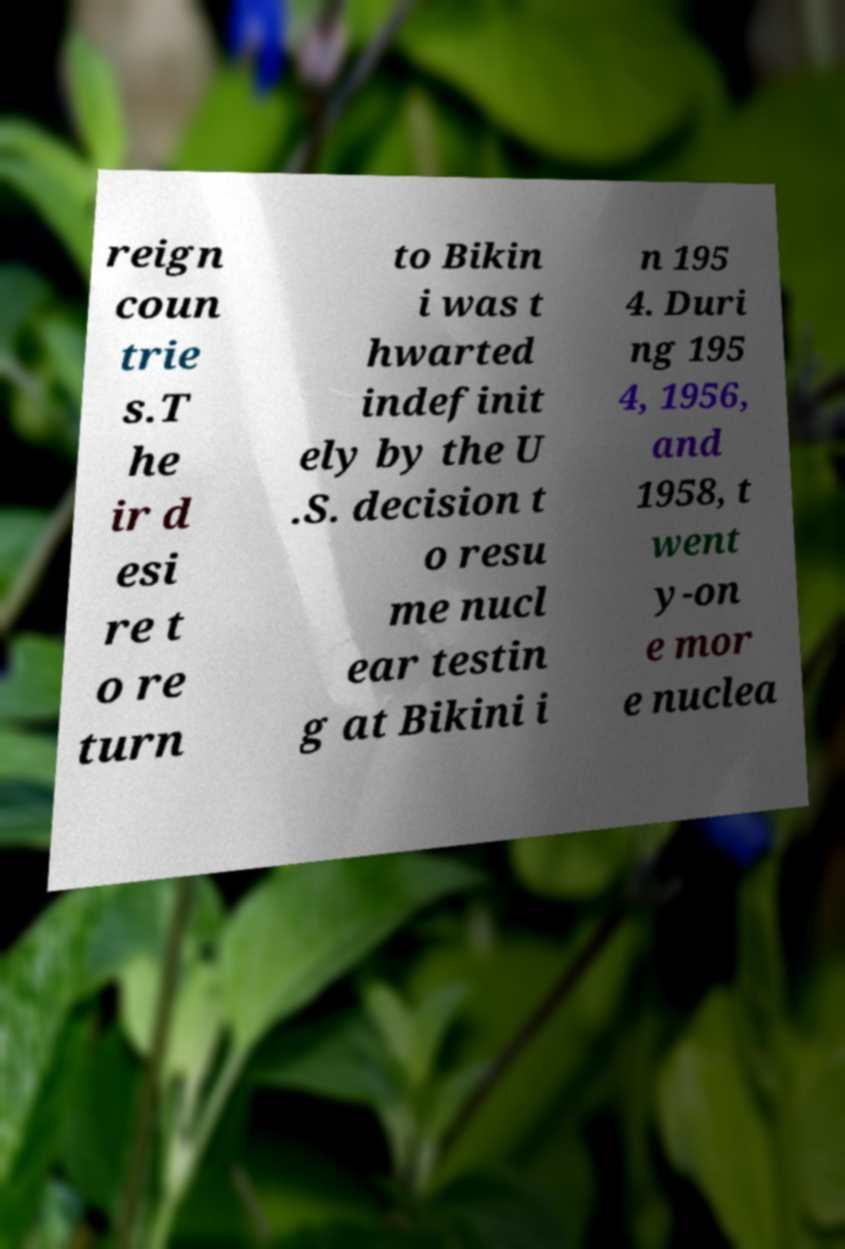For documentation purposes, I need the text within this image transcribed. Could you provide that? reign coun trie s.T he ir d esi re t o re turn to Bikin i was t hwarted indefinit ely by the U .S. decision t o resu me nucl ear testin g at Bikini i n 195 4. Duri ng 195 4, 1956, and 1958, t went y-on e mor e nuclea 